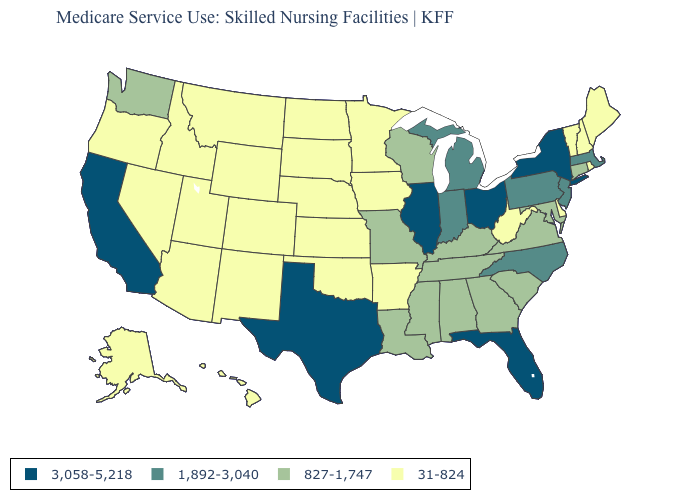Name the states that have a value in the range 1,892-3,040?
Give a very brief answer. Indiana, Massachusetts, Michigan, New Jersey, North Carolina, Pennsylvania. What is the value of New Mexico?
Short answer required. 31-824. What is the highest value in the USA?
Quick response, please. 3,058-5,218. What is the value of Idaho?
Short answer required. 31-824. Does the map have missing data?
Keep it brief. No. Name the states that have a value in the range 1,892-3,040?
Write a very short answer. Indiana, Massachusetts, Michigan, New Jersey, North Carolina, Pennsylvania. How many symbols are there in the legend?
Answer briefly. 4. How many symbols are there in the legend?
Short answer required. 4. What is the lowest value in the MidWest?
Write a very short answer. 31-824. Which states have the lowest value in the USA?
Quick response, please. Alaska, Arizona, Arkansas, Colorado, Delaware, Hawaii, Idaho, Iowa, Kansas, Maine, Minnesota, Montana, Nebraska, Nevada, New Hampshire, New Mexico, North Dakota, Oklahoma, Oregon, Rhode Island, South Dakota, Utah, Vermont, West Virginia, Wyoming. Does Ohio have the same value as Texas?
Be succinct. Yes. Name the states that have a value in the range 3,058-5,218?
Give a very brief answer. California, Florida, Illinois, New York, Ohio, Texas. What is the value of Nebraska?
Answer briefly. 31-824. Which states have the highest value in the USA?
Be succinct. California, Florida, Illinois, New York, Ohio, Texas. Does Indiana have the same value as Washington?
Keep it brief. No. 